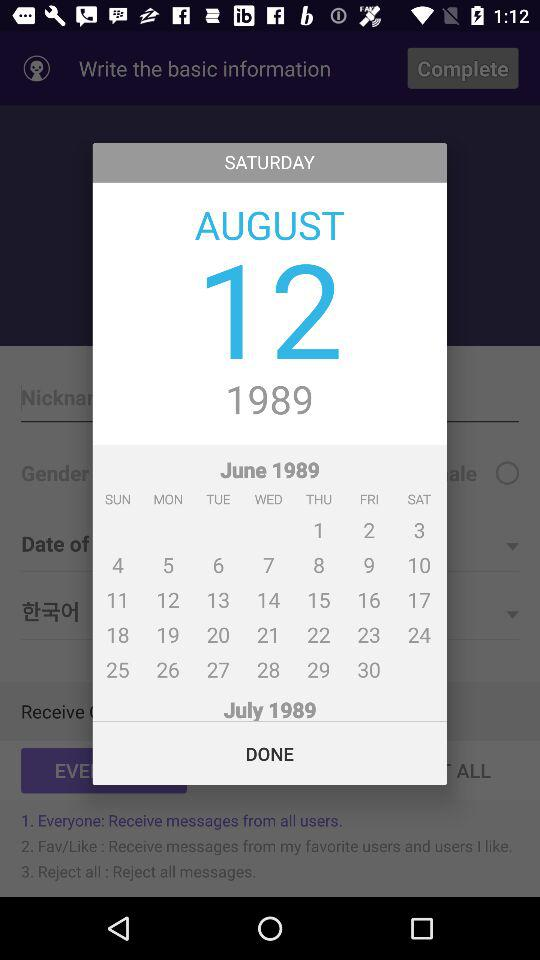What is the day on the 15th of August? The day is "Thursday". 